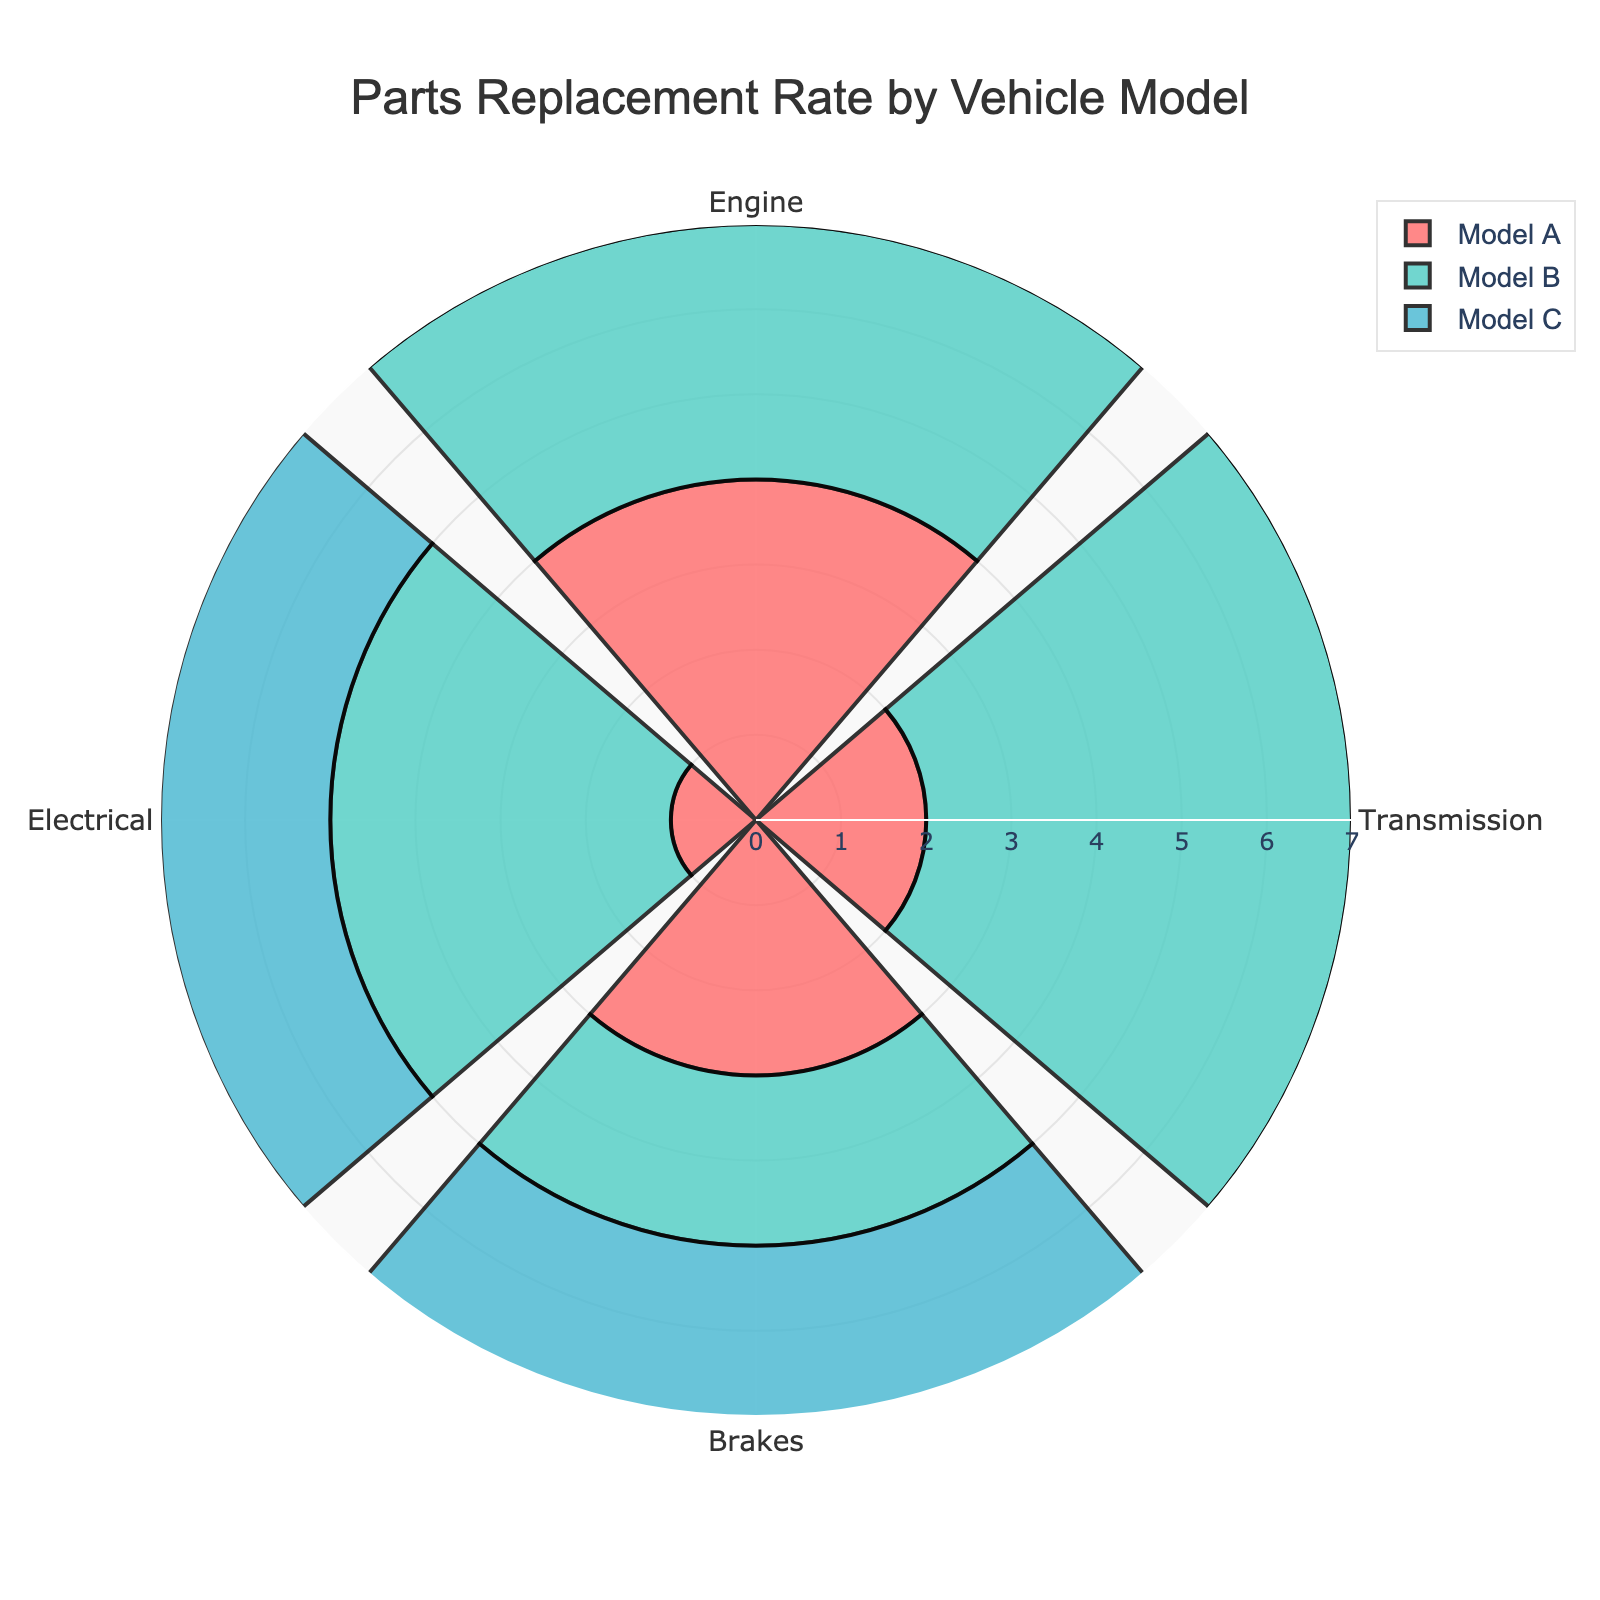What is the title of the figure? The title is usually found at the top of the chart.
Answer: Parts Replacement Rate by Vehicle Model Which vehicle model has the highest replacement rate for the engine? Compare the engine replacement rates for all vehicle models and identify the highest one. Model C's engine replacement rate is 6, which is the highest.
Answer: Model C How many types of parts are shown in the figure? Count the number of categories listed for parts replacement rates.
Answer: 4 Which part has the lowest replacement rate in Model A? Look at the values for Model A and find the lowest one. The electrical part has the lowest rate of 1.
Answer: Electrical What is the total replacement rate for all parts in Model B? Sum up all the replacement rates for Model B. The rates are 3 (Engine), 5 (Transmission), 2 (Brakes), and 4 (Electrical). 3 + 5 + 2 + 4 = 14.
Answer: 14 How does the transmission replacement rate for Model B compare to Model C? Compare the transmission replacement rate values for both models. Model B's rate is 5, and Model C's rate is 3.
Answer: Model B's rate is higher Which model has the highest overall replacement rate across all parts? Calculate the total replacement rate for each model by summing their part replacement rates. Model A: 4+2+3+1=10, Model B: 3+5+2+4=14, Model C: 6+3+4+2=15. The highest is Model C.
Answer: Model C Is the brakes replacement rate for Model C greater than the engine replacement rate for Model B? Compare the brakes replacement rate for Model C (4) with the engine replacement rate for Model B (3).
Answer: Yes Which model has the smallest difference between the highest and lowest part replacement rates? Calculate the difference between the highest and lowest replacement rates for each model. Model A: 4-1=3, Model B: 5-2=3, Model C: 6-2=4. The smallest difference is in Model A and Model B, both 3.
Answer: Model A, Model B What is the average replacement rate for electrical parts across all models? Sum up the replacement rates for electrical parts across all models and divide by the number of models. (1+4+2)/3 = 2.33.
Answer: 2.33 